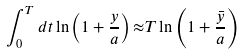<formula> <loc_0><loc_0><loc_500><loc_500>\int _ { 0 } ^ { T } d t \ln \left ( 1 + \frac { y } { a } \right ) { \approx } T \ln \left ( 1 + \frac { \bar { y } } { a } \right )</formula> 